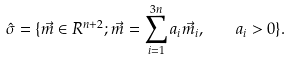<formula> <loc_0><loc_0><loc_500><loc_500>\hat { \sigma } = \{ \vec { m } \in { R } ^ { n + 2 } ; \vec { m } = \sum _ { i = 1 } ^ { 3 n } a _ { i } \vec { m } _ { i } , \quad a _ { i } > 0 \} .</formula> 